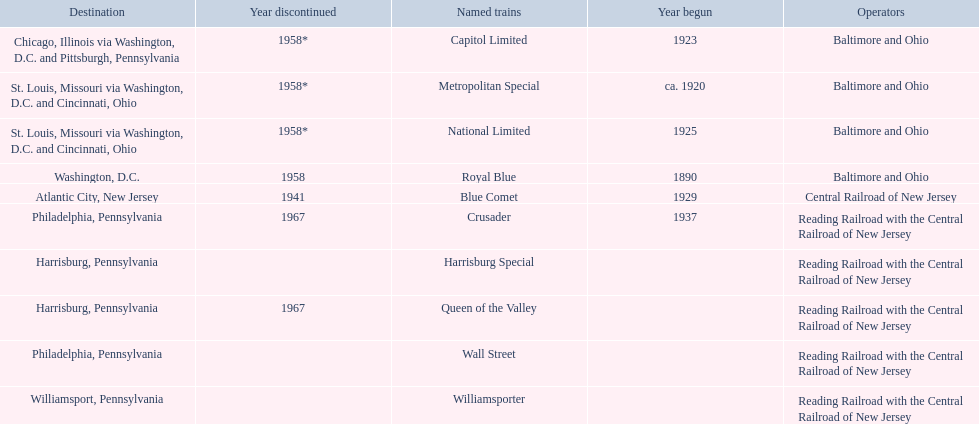Which operators are the reading railroad with the central railroad of new jersey? Reading Railroad with the Central Railroad of New Jersey, Reading Railroad with the Central Railroad of New Jersey, Reading Railroad with the Central Railroad of New Jersey, Reading Railroad with the Central Railroad of New Jersey, Reading Railroad with the Central Railroad of New Jersey. Which destinations are philadelphia, pennsylvania? Philadelphia, Pennsylvania, Philadelphia, Pennsylvania. What on began in 1937? 1937. What is the named train? Crusader. 